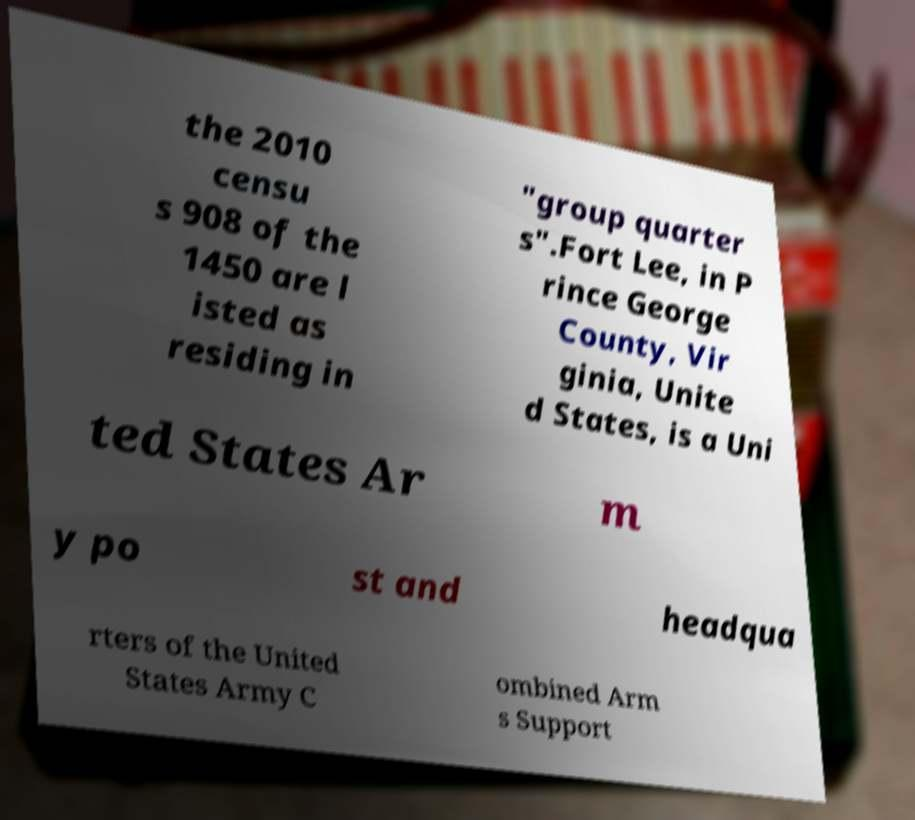Can you accurately transcribe the text from the provided image for me? the 2010 censu s 908 of the 1450 are l isted as residing in "group quarter s".Fort Lee, in P rince George County, Vir ginia, Unite d States, is a Uni ted States Ar m y po st and headqua rters of the United States Army C ombined Arm s Support 